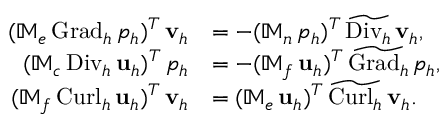Convert formula to latex. <formula><loc_0><loc_0><loc_500><loc_500>\begin{array} { r l } { ( \mathbb { M } _ { e } \, { G r a d _ { h } } \, p _ { h } ) ^ { T } \, v _ { h } } & { = - ( \mathbb { M } _ { n } \, p _ { h } ) ^ { T } \, \widetilde { D i v _ { h } } \, v _ { h } , } \\ { ( \mathbb { M } _ { c } \, { D i v _ { h } } \, u _ { h } ) ^ { T } \, p _ { h } } & { = - ( \mathbb { M } _ { f } \, u _ { h } ) ^ { T } \, \widetilde { G r a d _ { h } } \, p _ { h } , } \\ { ( \mathbb { M } _ { f } \, { C u r l _ { h } } \, u _ { h } ) ^ { T } \, v _ { h } } & { = ( \mathbb { M } _ { e } \, u _ { h } ) ^ { T } \, \widetilde { C u r l _ { h } } \, v _ { h } . } \end{array}</formula> 